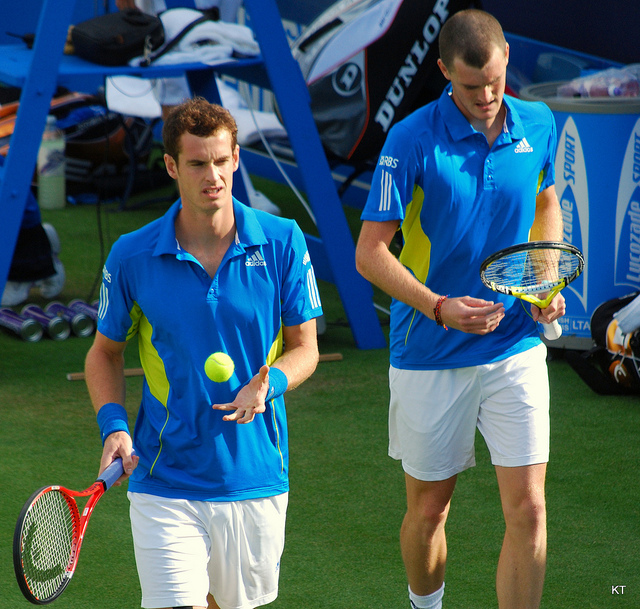Please transcribe the text information in this image. SPORT DUNLOP KT 